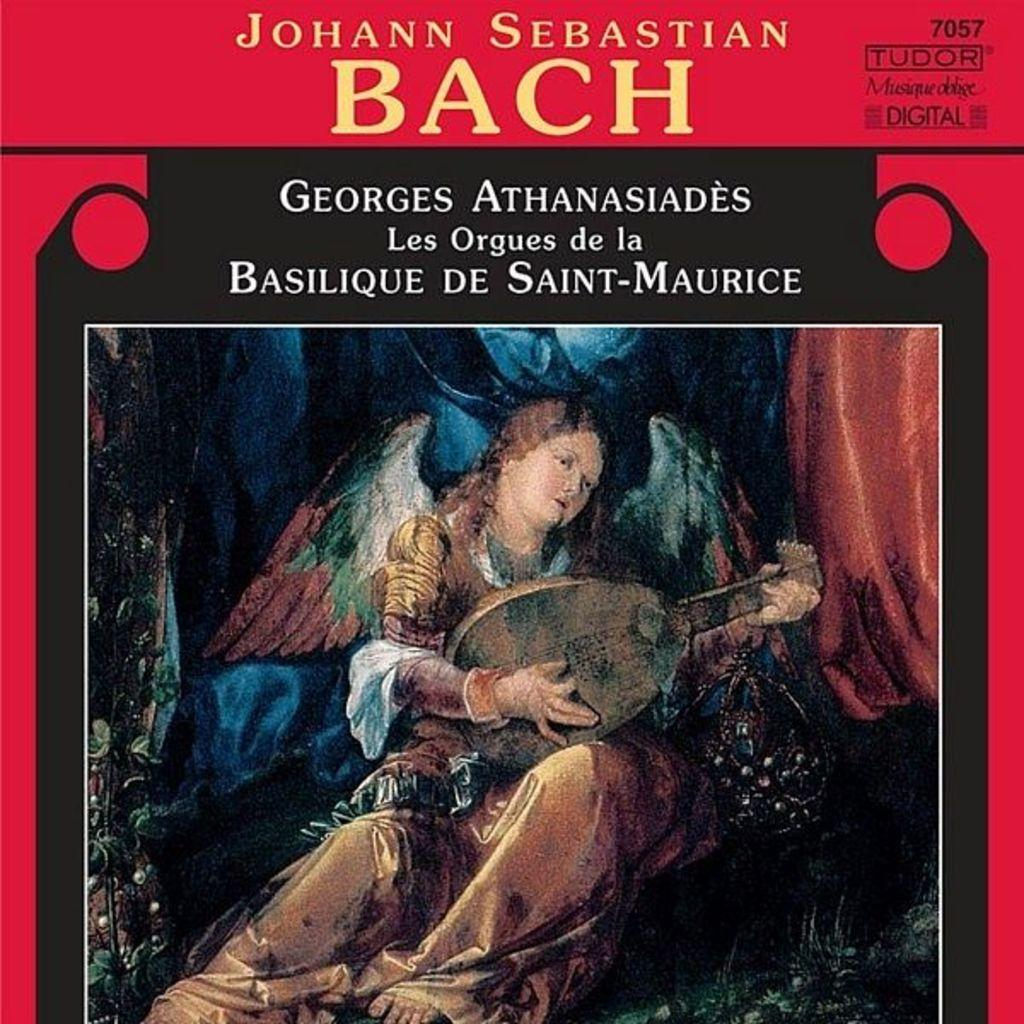<image>
Summarize the visual content of the image. Artwork for a piece of music by Johann Sebastian Bach. 